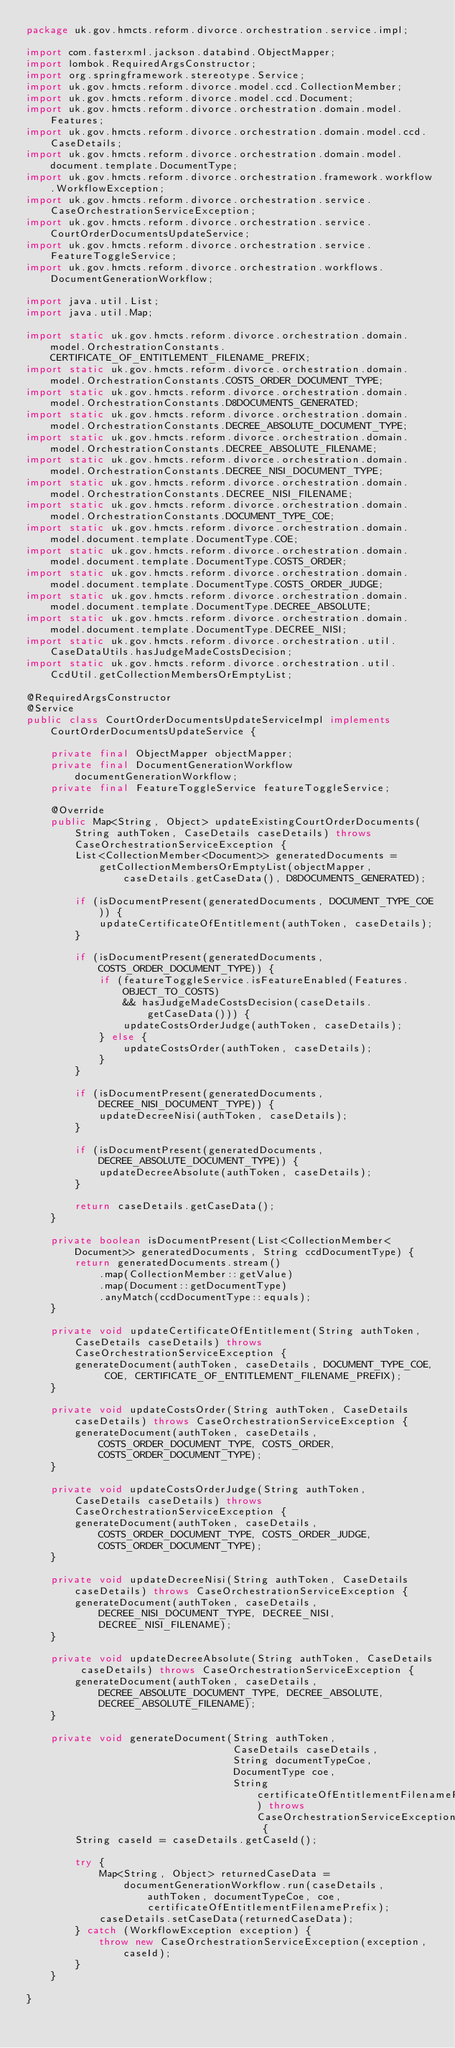Convert code to text. <code><loc_0><loc_0><loc_500><loc_500><_Java_>package uk.gov.hmcts.reform.divorce.orchestration.service.impl;

import com.fasterxml.jackson.databind.ObjectMapper;
import lombok.RequiredArgsConstructor;
import org.springframework.stereotype.Service;
import uk.gov.hmcts.reform.divorce.model.ccd.CollectionMember;
import uk.gov.hmcts.reform.divorce.model.ccd.Document;
import uk.gov.hmcts.reform.divorce.orchestration.domain.model.Features;
import uk.gov.hmcts.reform.divorce.orchestration.domain.model.ccd.CaseDetails;
import uk.gov.hmcts.reform.divorce.orchestration.domain.model.document.template.DocumentType;
import uk.gov.hmcts.reform.divorce.orchestration.framework.workflow.WorkflowException;
import uk.gov.hmcts.reform.divorce.orchestration.service.CaseOrchestrationServiceException;
import uk.gov.hmcts.reform.divorce.orchestration.service.CourtOrderDocumentsUpdateService;
import uk.gov.hmcts.reform.divorce.orchestration.service.FeatureToggleService;
import uk.gov.hmcts.reform.divorce.orchestration.workflows.DocumentGenerationWorkflow;

import java.util.List;
import java.util.Map;

import static uk.gov.hmcts.reform.divorce.orchestration.domain.model.OrchestrationConstants.CERTIFICATE_OF_ENTITLEMENT_FILENAME_PREFIX;
import static uk.gov.hmcts.reform.divorce.orchestration.domain.model.OrchestrationConstants.COSTS_ORDER_DOCUMENT_TYPE;
import static uk.gov.hmcts.reform.divorce.orchestration.domain.model.OrchestrationConstants.D8DOCUMENTS_GENERATED;
import static uk.gov.hmcts.reform.divorce.orchestration.domain.model.OrchestrationConstants.DECREE_ABSOLUTE_DOCUMENT_TYPE;
import static uk.gov.hmcts.reform.divorce.orchestration.domain.model.OrchestrationConstants.DECREE_ABSOLUTE_FILENAME;
import static uk.gov.hmcts.reform.divorce.orchestration.domain.model.OrchestrationConstants.DECREE_NISI_DOCUMENT_TYPE;
import static uk.gov.hmcts.reform.divorce.orchestration.domain.model.OrchestrationConstants.DECREE_NISI_FILENAME;
import static uk.gov.hmcts.reform.divorce.orchestration.domain.model.OrchestrationConstants.DOCUMENT_TYPE_COE;
import static uk.gov.hmcts.reform.divorce.orchestration.domain.model.document.template.DocumentType.COE;
import static uk.gov.hmcts.reform.divorce.orchestration.domain.model.document.template.DocumentType.COSTS_ORDER;
import static uk.gov.hmcts.reform.divorce.orchestration.domain.model.document.template.DocumentType.COSTS_ORDER_JUDGE;
import static uk.gov.hmcts.reform.divorce.orchestration.domain.model.document.template.DocumentType.DECREE_ABSOLUTE;
import static uk.gov.hmcts.reform.divorce.orchestration.domain.model.document.template.DocumentType.DECREE_NISI;
import static uk.gov.hmcts.reform.divorce.orchestration.util.CaseDataUtils.hasJudgeMadeCostsDecision;
import static uk.gov.hmcts.reform.divorce.orchestration.util.CcdUtil.getCollectionMembersOrEmptyList;

@RequiredArgsConstructor
@Service
public class CourtOrderDocumentsUpdateServiceImpl implements CourtOrderDocumentsUpdateService {

    private final ObjectMapper objectMapper;
    private final DocumentGenerationWorkflow documentGenerationWorkflow;
    private final FeatureToggleService featureToggleService;

    @Override
    public Map<String, Object> updateExistingCourtOrderDocuments(String authToken, CaseDetails caseDetails) throws CaseOrchestrationServiceException {
        List<CollectionMember<Document>> generatedDocuments =
            getCollectionMembersOrEmptyList(objectMapper, caseDetails.getCaseData(), D8DOCUMENTS_GENERATED);

        if (isDocumentPresent(generatedDocuments, DOCUMENT_TYPE_COE)) {
            updateCertificateOfEntitlement(authToken, caseDetails);
        }

        if (isDocumentPresent(generatedDocuments, COSTS_ORDER_DOCUMENT_TYPE)) {
            if (featureToggleService.isFeatureEnabled(Features.OBJECT_TO_COSTS)
                && hasJudgeMadeCostsDecision(caseDetails.getCaseData())) {
                updateCostsOrderJudge(authToken, caseDetails);
            } else {
                updateCostsOrder(authToken, caseDetails);
            }
        }

        if (isDocumentPresent(generatedDocuments, DECREE_NISI_DOCUMENT_TYPE)) {
            updateDecreeNisi(authToken, caseDetails);
        }

        if (isDocumentPresent(generatedDocuments, DECREE_ABSOLUTE_DOCUMENT_TYPE)) {
            updateDecreeAbsolute(authToken, caseDetails);
        }

        return caseDetails.getCaseData();
    }

    private boolean isDocumentPresent(List<CollectionMember<Document>> generatedDocuments, String ccdDocumentType) {
        return generatedDocuments.stream()
            .map(CollectionMember::getValue)
            .map(Document::getDocumentType)
            .anyMatch(ccdDocumentType::equals);
    }

    private void updateCertificateOfEntitlement(String authToken, CaseDetails caseDetails) throws CaseOrchestrationServiceException {
        generateDocument(authToken, caseDetails, DOCUMENT_TYPE_COE, COE, CERTIFICATE_OF_ENTITLEMENT_FILENAME_PREFIX);
    }

    private void updateCostsOrder(String authToken, CaseDetails caseDetails) throws CaseOrchestrationServiceException {
        generateDocument(authToken, caseDetails, COSTS_ORDER_DOCUMENT_TYPE, COSTS_ORDER, COSTS_ORDER_DOCUMENT_TYPE);
    }

    private void updateCostsOrderJudge(String authToken, CaseDetails caseDetails) throws CaseOrchestrationServiceException {
        generateDocument(authToken, caseDetails, COSTS_ORDER_DOCUMENT_TYPE, COSTS_ORDER_JUDGE, COSTS_ORDER_DOCUMENT_TYPE);
    }

    private void updateDecreeNisi(String authToken, CaseDetails caseDetails) throws CaseOrchestrationServiceException {
        generateDocument(authToken, caseDetails, DECREE_NISI_DOCUMENT_TYPE, DECREE_NISI, DECREE_NISI_FILENAME);
    }

    private void updateDecreeAbsolute(String authToken, CaseDetails caseDetails) throws CaseOrchestrationServiceException {
        generateDocument(authToken, caseDetails, DECREE_ABSOLUTE_DOCUMENT_TYPE, DECREE_ABSOLUTE, DECREE_ABSOLUTE_FILENAME);
    }

    private void generateDocument(String authToken,
                                  CaseDetails caseDetails,
                                  String documentTypeCoe,
                                  DocumentType coe,
                                  String certificateOfEntitlementFilenamePrefix) throws CaseOrchestrationServiceException {
        String caseId = caseDetails.getCaseId();

        try {
            Map<String, Object> returnedCaseData =
                documentGenerationWorkflow.run(caseDetails, authToken, documentTypeCoe, coe, certificateOfEntitlementFilenamePrefix);
            caseDetails.setCaseData(returnedCaseData);
        } catch (WorkflowException exception) {
            throw new CaseOrchestrationServiceException(exception, caseId);
        }
    }

}</code> 